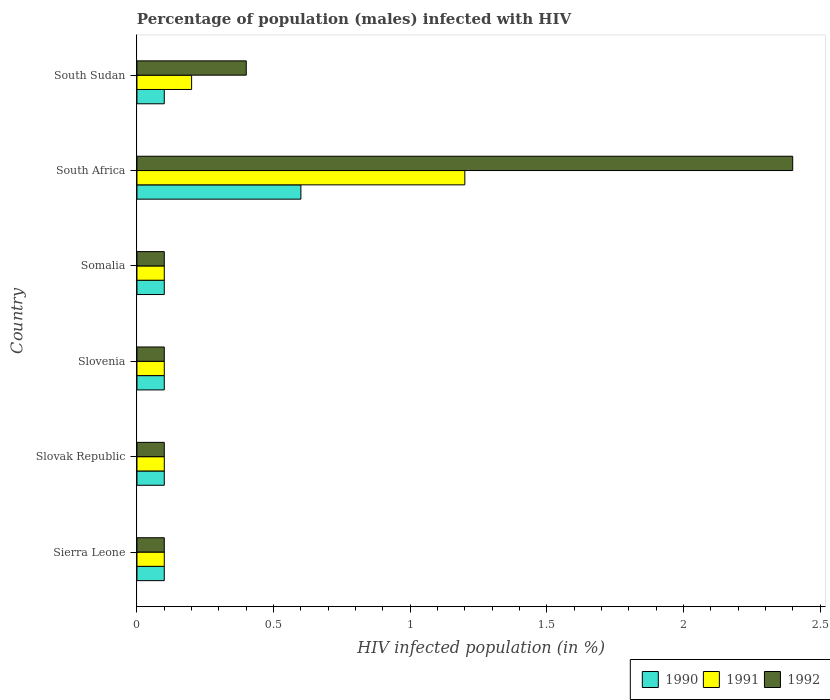How many groups of bars are there?
Give a very brief answer. 6. Are the number of bars on each tick of the Y-axis equal?
Make the answer very short. Yes. How many bars are there on the 2nd tick from the top?
Provide a short and direct response. 3. What is the label of the 4th group of bars from the top?
Make the answer very short. Slovenia. In how many cases, is the number of bars for a given country not equal to the number of legend labels?
Make the answer very short. 0. Across all countries, what is the maximum percentage of HIV infected male population in 1991?
Your response must be concise. 1.2. In which country was the percentage of HIV infected male population in 1990 maximum?
Offer a terse response. South Africa. In which country was the percentage of HIV infected male population in 1991 minimum?
Provide a succinct answer. Sierra Leone. What is the total percentage of HIV infected male population in 1990 in the graph?
Ensure brevity in your answer.  1.1. What is the difference between the percentage of HIV infected male population in 1990 in Somalia and that in South Africa?
Give a very brief answer. -0.5. What is the difference between the percentage of HIV infected male population in 1990 and percentage of HIV infected male population in 1992 in Sierra Leone?
Your answer should be compact. 0. What is the ratio of the percentage of HIV infected male population in 1992 in Slovenia to that in Somalia?
Give a very brief answer. 1. What is the difference between the highest and the lowest percentage of HIV infected male population in 1992?
Make the answer very short. 2.3. What does the 3rd bar from the bottom in Somalia represents?
Offer a terse response. 1992. Are all the bars in the graph horizontal?
Ensure brevity in your answer.  Yes. How many countries are there in the graph?
Make the answer very short. 6. Are the values on the major ticks of X-axis written in scientific E-notation?
Offer a terse response. No. Does the graph contain grids?
Keep it short and to the point. No. How many legend labels are there?
Your answer should be compact. 3. What is the title of the graph?
Make the answer very short. Percentage of population (males) infected with HIV. What is the label or title of the X-axis?
Offer a terse response. HIV infected population (in %). What is the HIV infected population (in %) of 1990 in Sierra Leone?
Provide a short and direct response. 0.1. What is the HIV infected population (in %) in 1992 in Sierra Leone?
Your response must be concise. 0.1. What is the HIV infected population (in %) in 1990 in Slovak Republic?
Make the answer very short. 0.1. What is the HIV infected population (in %) of 1992 in Slovak Republic?
Give a very brief answer. 0.1. What is the HIV infected population (in %) in 1991 in Slovenia?
Your answer should be very brief. 0.1. What is the HIV infected population (in %) of 1992 in Slovenia?
Offer a terse response. 0.1. What is the HIV infected population (in %) of 1990 in Somalia?
Your response must be concise. 0.1. What is the HIV infected population (in %) in 1990 in South Africa?
Make the answer very short. 0.6. What is the HIV infected population (in %) of 1991 in South Africa?
Offer a terse response. 1.2. What is the HIV infected population (in %) in 1990 in South Sudan?
Your answer should be compact. 0.1. What is the HIV infected population (in %) in 1991 in South Sudan?
Keep it short and to the point. 0.2. Across all countries, what is the maximum HIV infected population (in %) in 1991?
Ensure brevity in your answer.  1.2. Across all countries, what is the minimum HIV infected population (in %) of 1992?
Offer a very short reply. 0.1. What is the total HIV infected population (in %) in 1990 in the graph?
Provide a succinct answer. 1.1. What is the total HIV infected population (in %) in 1992 in the graph?
Keep it short and to the point. 3.2. What is the difference between the HIV infected population (in %) in 1990 in Sierra Leone and that in Slovak Republic?
Provide a short and direct response. 0. What is the difference between the HIV infected population (in %) of 1991 in Sierra Leone and that in Slovak Republic?
Offer a very short reply. 0. What is the difference between the HIV infected population (in %) in 1992 in Sierra Leone and that in Slovak Republic?
Your answer should be compact. 0. What is the difference between the HIV infected population (in %) in 1990 in Sierra Leone and that in Slovenia?
Provide a succinct answer. 0. What is the difference between the HIV infected population (in %) in 1991 in Sierra Leone and that in Somalia?
Provide a succinct answer. 0. What is the difference between the HIV infected population (in %) in 1992 in Sierra Leone and that in Somalia?
Give a very brief answer. 0. What is the difference between the HIV infected population (in %) of 1991 in Sierra Leone and that in South Africa?
Your response must be concise. -1.1. What is the difference between the HIV infected population (in %) in 1992 in Sierra Leone and that in South Sudan?
Keep it short and to the point. -0.3. What is the difference between the HIV infected population (in %) in 1990 in Slovak Republic and that in Slovenia?
Offer a very short reply. 0. What is the difference between the HIV infected population (in %) in 1992 in Slovak Republic and that in Somalia?
Your answer should be very brief. 0. What is the difference between the HIV infected population (in %) of 1992 in Slovak Republic and that in South Africa?
Make the answer very short. -2.3. What is the difference between the HIV infected population (in %) in 1992 in Slovak Republic and that in South Sudan?
Give a very brief answer. -0.3. What is the difference between the HIV infected population (in %) in 1991 in Slovenia and that in Somalia?
Make the answer very short. 0. What is the difference between the HIV infected population (in %) in 1992 in Slovenia and that in Somalia?
Make the answer very short. 0. What is the difference between the HIV infected population (in %) in 1990 in Slovenia and that in South Africa?
Give a very brief answer. -0.5. What is the difference between the HIV infected population (in %) of 1991 in Slovenia and that in South Africa?
Your answer should be very brief. -1.1. What is the difference between the HIV infected population (in %) in 1991 in Slovenia and that in South Sudan?
Offer a very short reply. -0.1. What is the difference between the HIV infected population (in %) of 1992 in Somalia and that in South Africa?
Offer a very short reply. -2.3. What is the difference between the HIV infected population (in %) of 1990 in Somalia and that in South Sudan?
Your answer should be very brief. 0. What is the difference between the HIV infected population (in %) in 1991 in Somalia and that in South Sudan?
Provide a short and direct response. -0.1. What is the difference between the HIV infected population (in %) in 1990 in Sierra Leone and the HIV infected population (in %) in 1991 in Slovak Republic?
Your answer should be compact. 0. What is the difference between the HIV infected population (in %) of 1991 in Sierra Leone and the HIV infected population (in %) of 1992 in Slovak Republic?
Offer a terse response. 0. What is the difference between the HIV infected population (in %) in 1990 in Sierra Leone and the HIV infected population (in %) in 1991 in Slovenia?
Offer a terse response. 0. What is the difference between the HIV infected population (in %) in 1990 in Sierra Leone and the HIV infected population (in %) in 1991 in Somalia?
Ensure brevity in your answer.  0. What is the difference between the HIV infected population (in %) in 1990 in Sierra Leone and the HIV infected population (in %) in 1992 in Somalia?
Provide a succinct answer. 0. What is the difference between the HIV infected population (in %) in 1990 in Sierra Leone and the HIV infected population (in %) in 1991 in South Sudan?
Give a very brief answer. -0.1. What is the difference between the HIV infected population (in %) in 1990 in Sierra Leone and the HIV infected population (in %) in 1992 in South Sudan?
Provide a short and direct response. -0.3. What is the difference between the HIV infected population (in %) in 1991 in Slovak Republic and the HIV infected population (in %) in 1992 in Slovenia?
Your answer should be very brief. 0. What is the difference between the HIV infected population (in %) of 1991 in Slovak Republic and the HIV infected population (in %) of 1992 in Somalia?
Ensure brevity in your answer.  0. What is the difference between the HIV infected population (in %) of 1991 in Slovak Republic and the HIV infected population (in %) of 1992 in South Africa?
Your answer should be compact. -2.3. What is the difference between the HIV infected population (in %) in 1990 in Slovak Republic and the HIV infected population (in %) in 1992 in South Sudan?
Your answer should be very brief. -0.3. What is the difference between the HIV infected population (in %) in 1991 in Slovak Republic and the HIV infected population (in %) in 1992 in South Sudan?
Make the answer very short. -0.3. What is the difference between the HIV infected population (in %) of 1990 in Slovenia and the HIV infected population (in %) of 1991 in Somalia?
Offer a very short reply. 0. What is the difference between the HIV infected population (in %) in 1990 in Slovenia and the HIV infected population (in %) in 1991 in South Sudan?
Make the answer very short. -0.1. What is the difference between the HIV infected population (in %) in 1990 in Slovenia and the HIV infected population (in %) in 1992 in South Sudan?
Your answer should be very brief. -0.3. What is the difference between the HIV infected population (in %) in 1990 in Somalia and the HIV infected population (in %) in 1992 in South Sudan?
Keep it short and to the point. -0.3. What is the difference between the HIV infected population (in %) in 1991 in South Africa and the HIV infected population (in %) in 1992 in South Sudan?
Your answer should be compact. 0.8. What is the average HIV infected population (in %) of 1990 per country?
Keep it short and to the point. 0.18. What is the average HIV infected population (in %) in 1991 per country?
Keep it short and to the point. 0.3. What is the average HIV infected population (in %) in 1992 per country?
Keep it short and to the point. 0.53. What is the difference between the HIV infected population (in %) in 1990 and HIV infected population (in %) in 1991 in Sierra Leone?
Provide a succinct answer. 0. What is the difference between the HIV infected population (in %) of 1990 and HIV infected population (in %) of 1991 in Slovak Republic?
Provide a succinct answer. 0. What is the difference between the HIV infected population (in %) in 1991 and HIV infected population (in %) in 1992 in Slovak Republic?
Provide a short and direct response. 0. What is the difference between the HIV infected population (in %) in 1990 and HIV infected population (in %) in 1991 in Slovenia?
Ensure brevity in your answer.  0. What is the difference between the HIV infected population (in %) of 1990 and HIV infected population (in %) of 1991 in Somalia?
Keep it short and to the point. 0. What is the difference between the HIV infected population (in %) of 1990 and HIV infected population (in %) of 1992 in Somalia?
Ensure brevity in your answer.  0. What is the difference between the HIV infected population (in %) in 1990 and HIV infected population (in %) in 1991 in South Africa?
Your answer should be very brief. -0.6. What is the difference between the HIV infected population (in %) of 1990 and HIV infected population (in %) of 1992 in South Sudan?
Provide a short and direct response. -0.3. What is the ratio of the HIV infected population (in %) of 1992 in Sierra Leone to that in Somalia?
Your answer should be very brief. 1. What is the ratio of the HIV infected population (in %) in 1991 in Sierra Leone to that in South Africa?
Provide a short and direct response. 0.08. What is the ratio of the HIV infected population (in %) of 1992 in Sierra Leone to that in South Africa?
Your answer should be compact. 0.04. What is the ratio of the HIV infected population (in %) in 1990 in Slovak Republic to that in Slovenia?
Your answer should be very brief. 1. What is the ratio of the HIV infected population (in %) in 1992 in Slovak Republic to that in Slovenia?
Give a very brief answer. 1. What is the ratio of the HIV infected population (in %) in 1990 in Slovak Republic to that in Somalia?
Your answer should be compact. 1. What is the ratio of the HIV infected population (in %) of 1991 in Slovak Republic to that in Somalia?
Offer a terse response. 1. What is the ratio of the HIV infected population (in %) in 1992 in Slovak Republic to that in Somalia?
Offer a very short reply. 1. What is the ratio of the HIV infected population (in %) in 1990 in Slovak Republic to that in South Africa?
Ensure brevity in your answer.  0.17. What is the ratio of the HIV infected population (in %) of 1991 in Slovak Republic to that in South Africa?
Your answer should be very brief. 0.08. What is the ratio of the HIV infected population (in %) of 1992 in Slovak Republic to that in South Africa?
Provide a short and direct response. 0.04. What is the ratio of the HIV infected population (in %) in 1990 in Slovak Republic to that in South Sudan?
Your answer should be very brief. 1. What is the ratio of the HIV infected population (in %) of 1992 in Slovak Republic to that in South Sudan?
Offer a terse response. 0.25. What is the ratio of the HIV infected population (in %) of 1990 in Slovenia to that in Somalia?
Offer a very short reply. 1. What is the ratio of the HIV infected population (in %) of 1991 in Slovenia to that in South Africa?
Give a very brief answer. 0.08. What is the ratio of the HIV infected population (in %) of 1992 in Slovenia to that in South Africa?
Ensure brevity in your answer.  0.04. What is the ratio of the HIV infected population (in %) of 1991 in Slovenia to that in South Sudan?
Provide a short and direct response. 0.5. What is the ratio of the HIV infected population (in %) in 1991 in Somalia to that in South Africa?
Make the answer very short. 0.08. What is the ratio of the HIV infected population (in %) of 1992 in Somalia to that in South Africa?
Keep it short and to the point. 0.04. What is the ratio of the HIV infected population (in %) in 1991 in Somalia to that in South Sudan?
Make the answer very short. 0.5. What is the ratio of the HIV infected population (in %) in 1992 in Somalia to that in South Sudan?
Your answer should be compact. 0.25. What is the ratio of the HIV infected population (in %) of 1991 in South Africa to that in South Sudan?
Your answer should be very brief. 6. What is the difference between the highest and the second highest HIV infected population (in %) of 1990?
Your answer should be compact. 0.5. What is the difference between the highest and the lowest HIV infected population (in %) in 1991?
Offer a terse response. 1.1. 